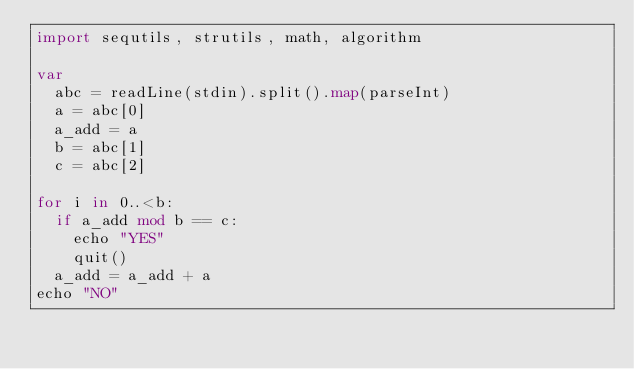Convert code to text. <code><loc_0><loc_0><loc_500><loc_500><_Nim_>import sequtils, strutils, math, algorithm

var
  abc = readLine(stdin).split().map(parseInt)
  a = abc[0]
  a_add = a
  b = abc[1]
  c = abc[2]

for i in 0..<b:
  if a_add mod b == c:
    echo "YES"
    quit()
  a_add = a_add + a
echo "NO"</code> 